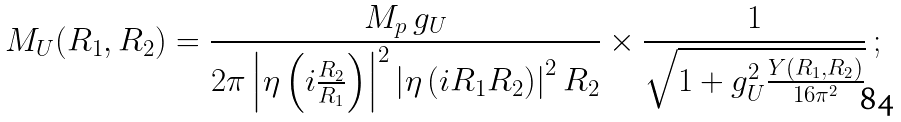Convert formula to latex. <formula><loc_0><loc_0><loc_500><loc_500>M _ { U } ( R _ { 1 } , R _ { 2 } ) = \frac { M _ { p } \, g _ { U } } { { 2 \pi } \left | \eta \left ( i \frac { R _ { 2 } } { R _ { 1 } } \right ) \right | ^ { 2 } \left | \eta \left ( i R _ { 1 } R _ { 2 } \right ) \right | ^ { 2 } R _ { 2 } } \times \frac { 1 } { \sqrt { 1 + g _ { U } ^ { 2 } \frac { Y ( R _ { 1 } , R _ { 2 } ) } { 1 6 \pi ^ { 2 } } } } \ ;</formula> 